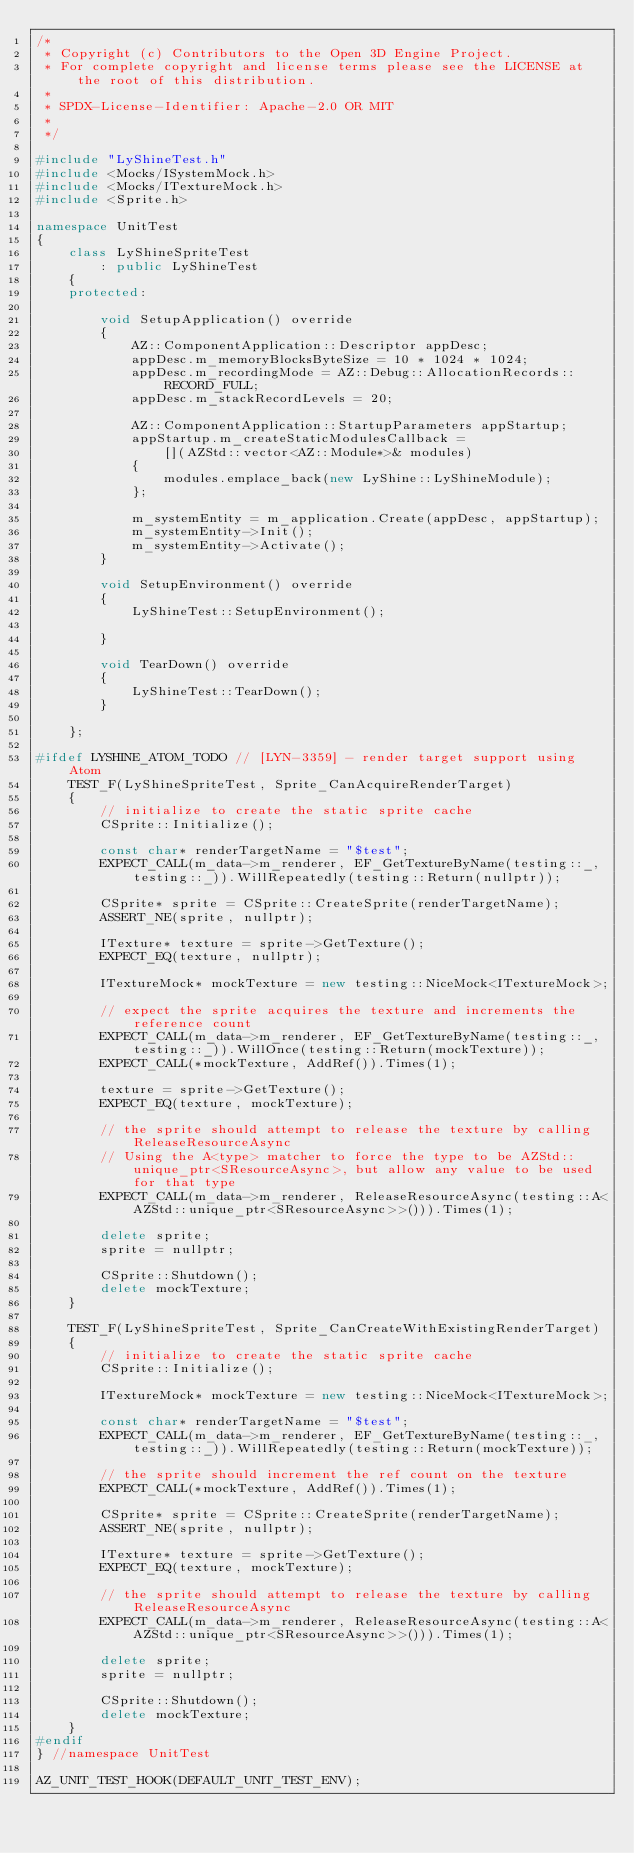Convert code to text. <code><loc_0><loc_0><loc_500><loc_500><_C++_>/*
 * Copyright (c) Contributors to the Open 3D Engine Project.
 * For complete copyright and license terms please see the LICENSE at the root of this distribution.
 *
 * SPDX-License-Identifier: Apache-2.0 OR MIT
 *
 */

#include "LyShineTest.h"
#include <Mocks/ISystemMock.h>
#include <Mocks/ITextureMock.h>
#include <Sprite.h>

namespace UnitTest
{
    class LyShineSpriteTest
        : public LyShineTest
    {
    protected:

        void SetupApplication() override
        {
            AZ::ComponentApplication::Descriptor appDesc;
            appDesc.m_memoryBlocksByteSize = 10 * 1024 * 1024;
            appDesc.m_recordingMode = AZ::Debug::AllocationRecords::RECORD_FULL;
            appDesc.m_stackRecordLevels = 20;

            AZ::ComponentApplication::StartupParameters appStartup;
            appStartup.m_createStaticModulesCallback =
                [](AZStd::vector<AZ::Module*>& modules)
            {
                modules.emplace_back(new LyShine::LyShineModule);
            };

            m_systemEntity = m_application.Create(appDesc, appStartup);
            m_systemEntity->Init();
            m_systemEntity->Activate();
        }

        void SetupEnvironment() override
        {
            LyShineTest::SetupEnvironment();

        }

        void TearDown() override
        {
            LyShineTest::TearDown();
        }

    };

#ifdef LYSHINE_ATOM_TODO // [LYN-3359] - render target support using Atom
    TEST_F(LyShineSpriteTest, Sprite_CanAcquireRenderTarget)
    {
        // initialize to create the static sprite cache
        CSprite::Initialize();

        const char* renderTargetName = "$test";
        EXPECT_CALL(m_data->m_renderer, EF_GetTextureByName(testing::_, testing::_)).WillRepeatedly(testing::Return(nullptr));

        CSprite* sprite = CSprite::CreateSprite(renderTargetName);
        ASSERT_NE(sprite, nullptr);

        ITexture* texture = sprite->GetTexture();
        EXPECT_EQ(texture, nullptr);

        ITextureMock* mockTexture = new testing::NiceMock<ITextureMock>;

        // expect the sprite acquires the texture and increments the reference count
        EXPECT_CALL(m_data->m_renderer, EF_GetTextureByName(testing::_, testing::_)).WillOnce(testing::Return(mockTexture));
        EXPECT_CALL(*mockTexture, AddRef()).Times(1);

        texture = sprite->GetTexture();
        EXPECT_EQ(texture, mockTexture);

        // the sprite should attempt to release the texture by calling ReleaseResourceAsync
        // Using the A<type> matcher to force the type to be AZStd::unique_ptr<SResourceAsync>, but allow any value to be used for that type
        EXPECT_CALL(m_data->m_renderer, ReleaseResourceAsync(testing::A<AZStd::unique_ptr<SResourceAsync>>())).Times(1);

        delete sprite;
        sprite = nullptr;

        CSprite::Shutdown();
        delete mockTexture;
    }

    TEST_F(LyShineSpriteTest, Sprite_CanCreateWithExistingRenderTarget)
    {
        // initialize to create the static sprite cache
        CSprite::Initialize();

        ITextureMock* mockTexture = new testing::NiceMock<ITextureMock>;

        const char* renderTargetName = "$test";
        EXPECT_CALL(m_data->m_renderer, EF_GetTextureByName(testing::_, testing::_)).WillRepeatedly(testing::Return(mockTexture));

        // the sprite should increment the ref count on the texture
        EXPECT_CALL(*mockTexture, AddRef()).Times(1);

        CSprite* sprite = CSprite::CreateSprite(renderTargetName);
        ASSERT_NE(sprite, nullptr);

        ITexture* texture = sprite->GetTexture();
        EXPECT_EQ(texture, mockTexture);

        // the sprite should attempt to release the texture by calling ReleaseResourceAsync
        EXPECT_CALL(m_data->m_renderer, ReleaseResourceAsync(testing::A<AZStd::unique_ptr<SResourceAsync>>())).Times(1);

        delete sprite;
        sprite = nullptr;

        CSprite::Shutdown();
        delete mockTexture;
    }
#endif
} //namespace UnitTest

AZ_UNIT_TEST_HOOK(DEFAULT_UNIT_TEST_ENV);
</code> 